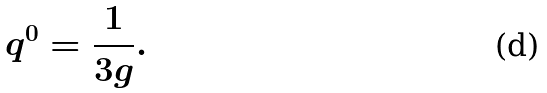Convert formula to latex. <formula><loc_0><loc_0><loc_500><loc_500>q ^ { 0 } = { \frac { 1 } { 3 g } . }</formula> 